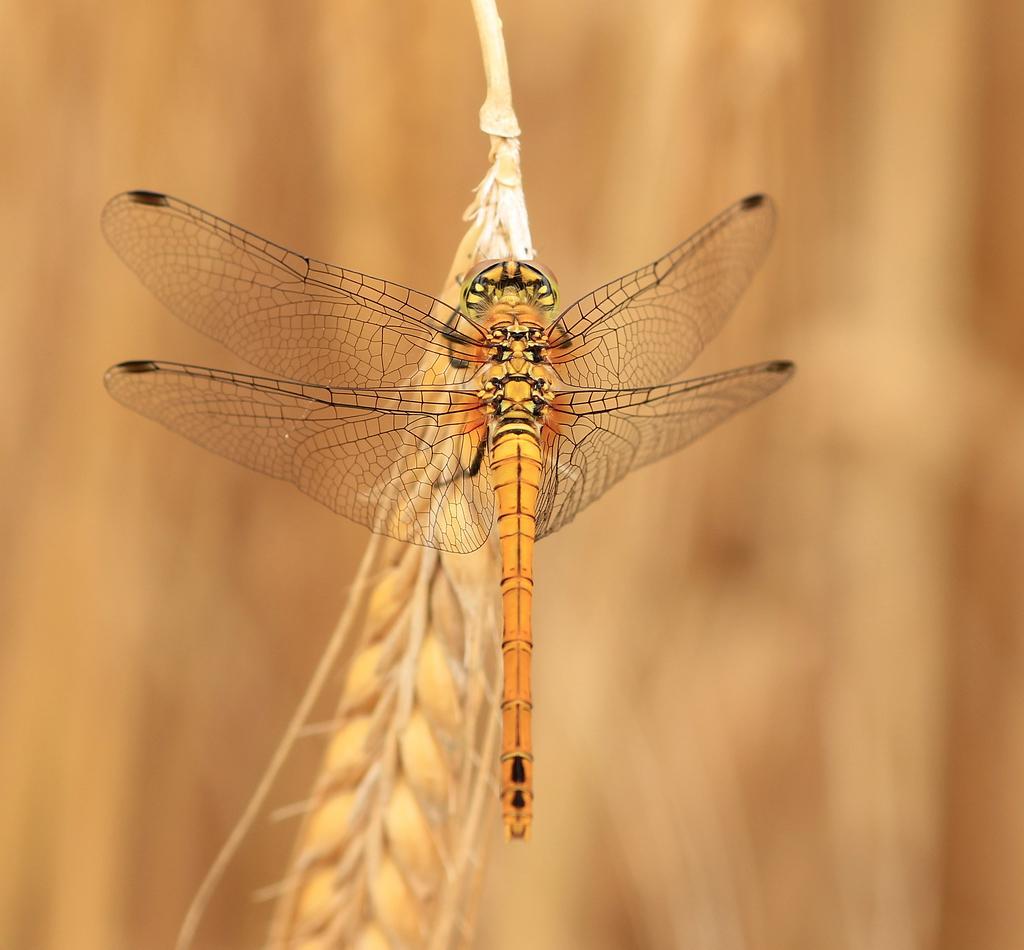Please provide a concise description of this image. In this image we can see an insect on the wheat plant and the background is blurred. 